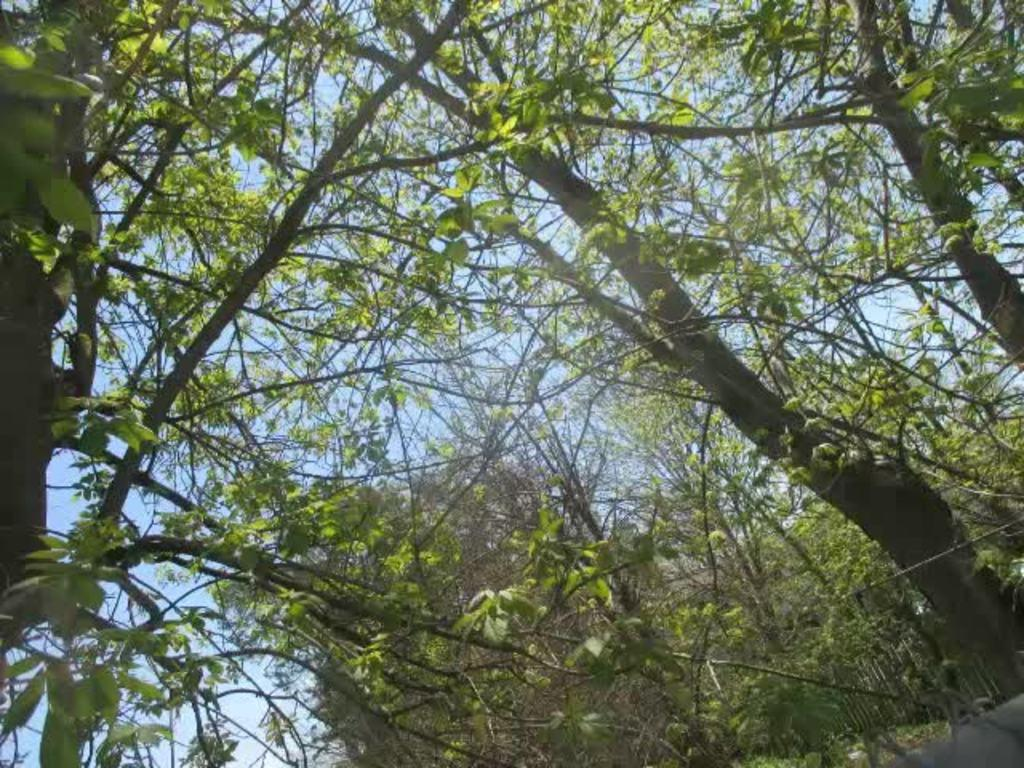What type of vegetation can be seen in the image? There are trees in the image. What type of government is depicted in the image? There is no government depicted in the image; it only features trees. How many pigs can be seen eating rice in the image? There are no pigs or rice present in the image, as it only features trees. 